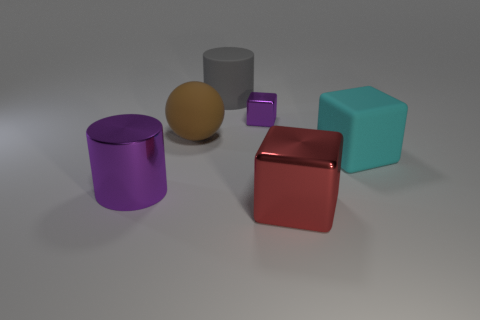What color is the cylinder that is the same material as the sphere? gray 